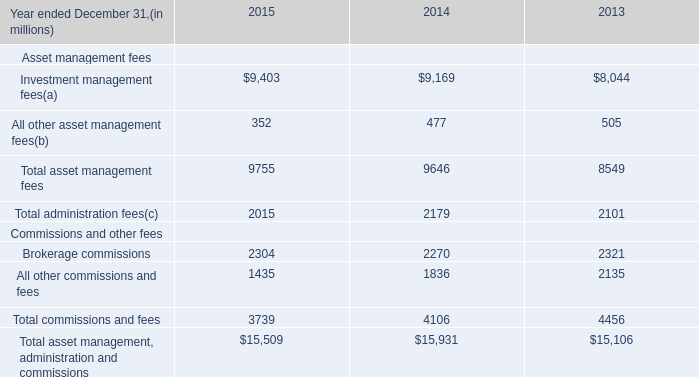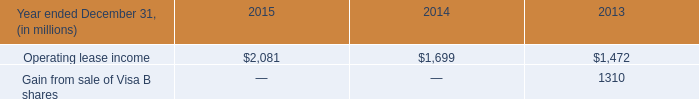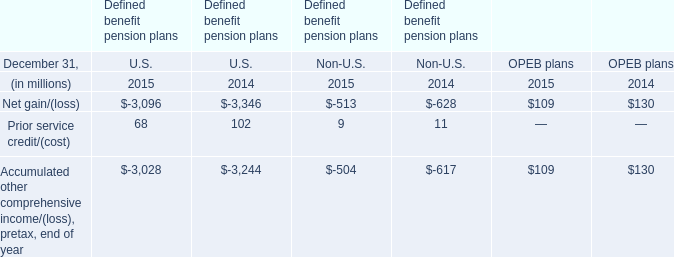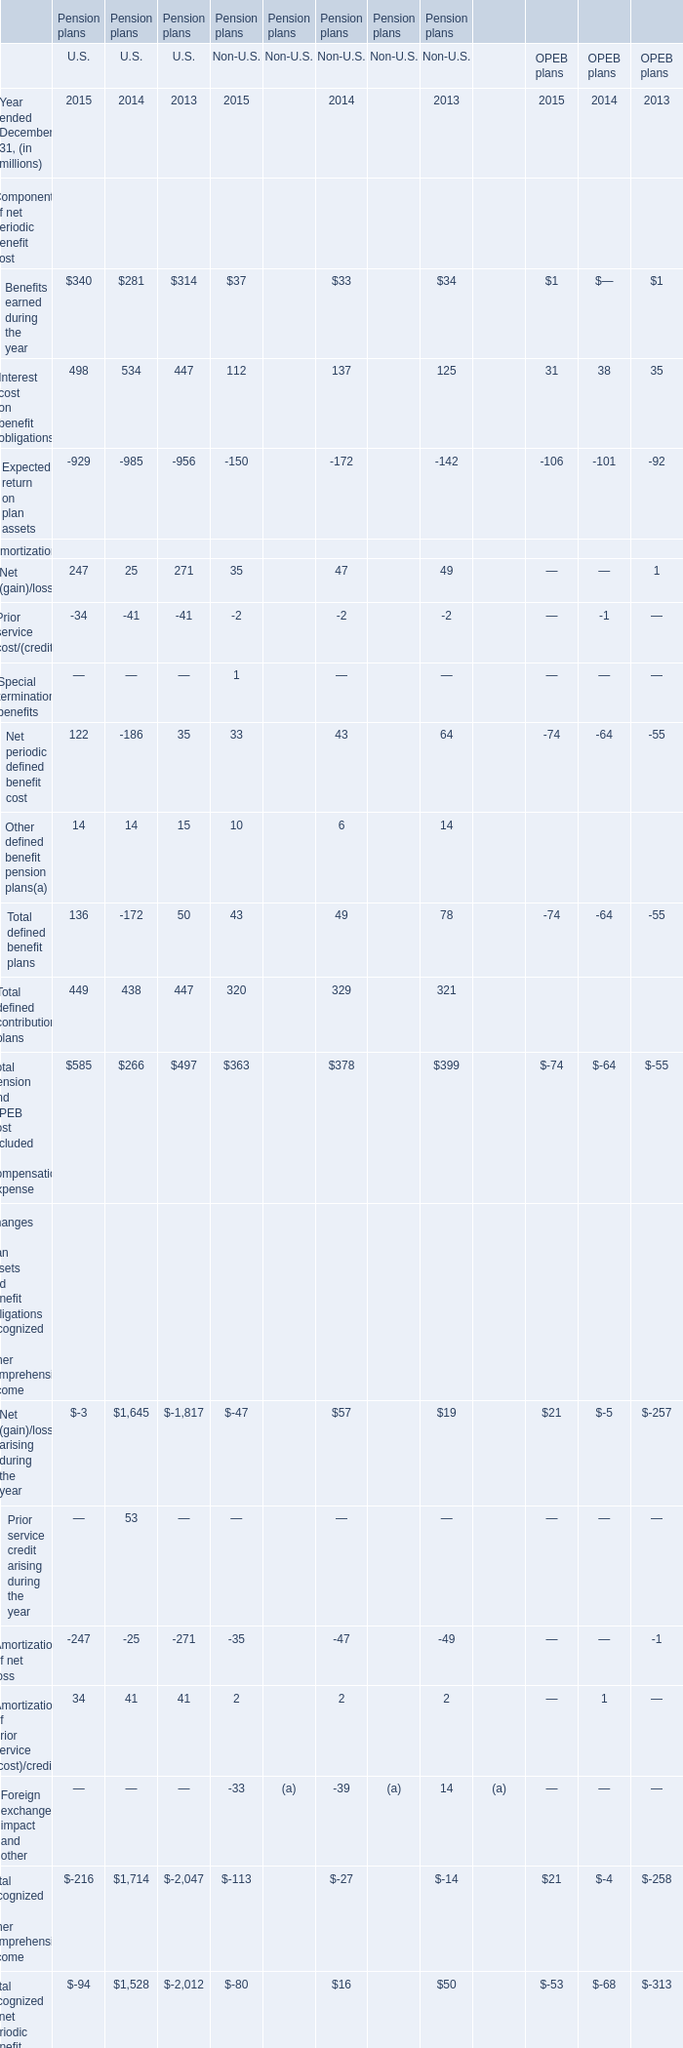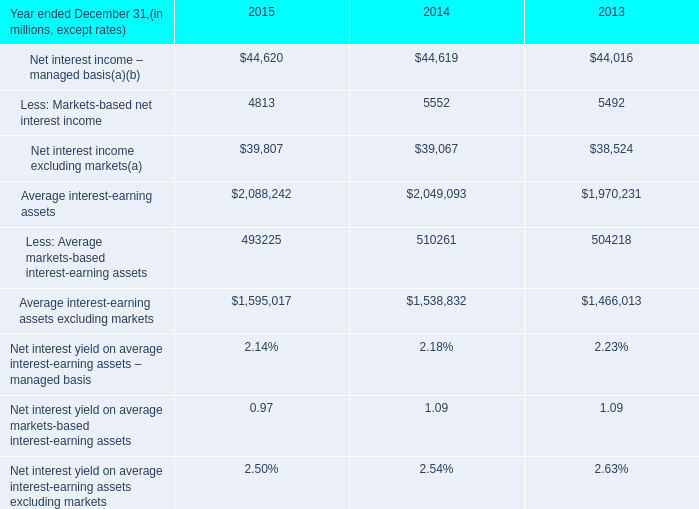in 2015 what was the percentage change in the net interest income excluding cib 2019s markets-based activities from 2014 
Computations: (740 / 39.8)
Answer: 18.59296. 